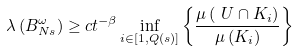<formula> <loc_0><loc_0><loc_500><loc_500>\lambda \left ( B _ { N s } ^ { \omega } \right ) & \geq c t ^ { - \beta } \inf _ { i \in [ 1 , Q ( s ) ] } \left \{ \frac { \mu \left ( \ U \cap K _ { i } \right ) } { \mu \left ( K _ { i } \right ) } \right \}</formula> 